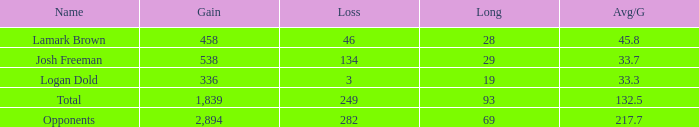Which Avg/G has a Name of josh freeman, and a Loss smaller than 134? None. Can you give me this table as a dict? {'header': ['Name', 'Gain', 'Loss', 'Long', 'Avg/G'], 'rows': [['Lamark Brown', '458', '46', '28', '45.8'], ['Josh Freeman', '538', '134', '29', '33.7'], ['Logan Dold', '336', '3', '19', '33.3'], ['Total', '1,839', '249', '93', '132.5'], ['Opponents', '2,894', '282', '69', '217.7']]} 